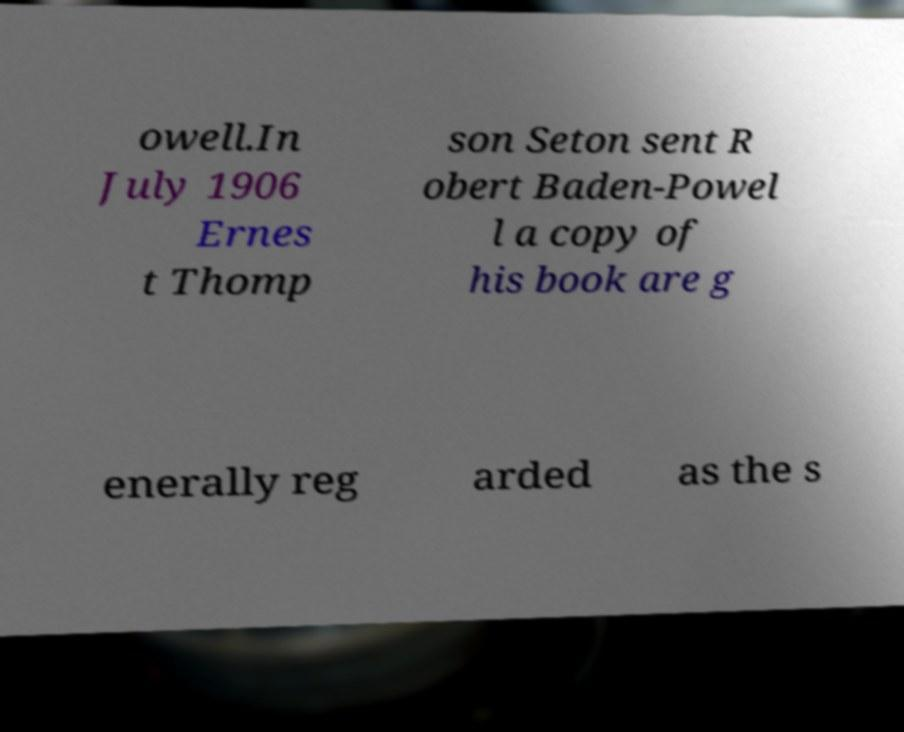Could you extract and type out the text from this image? owell.In July 1906 Ernes t Thomp son Seton sent R obert Baden-Powel l a copy of his book are g enerally reg arded as the s 